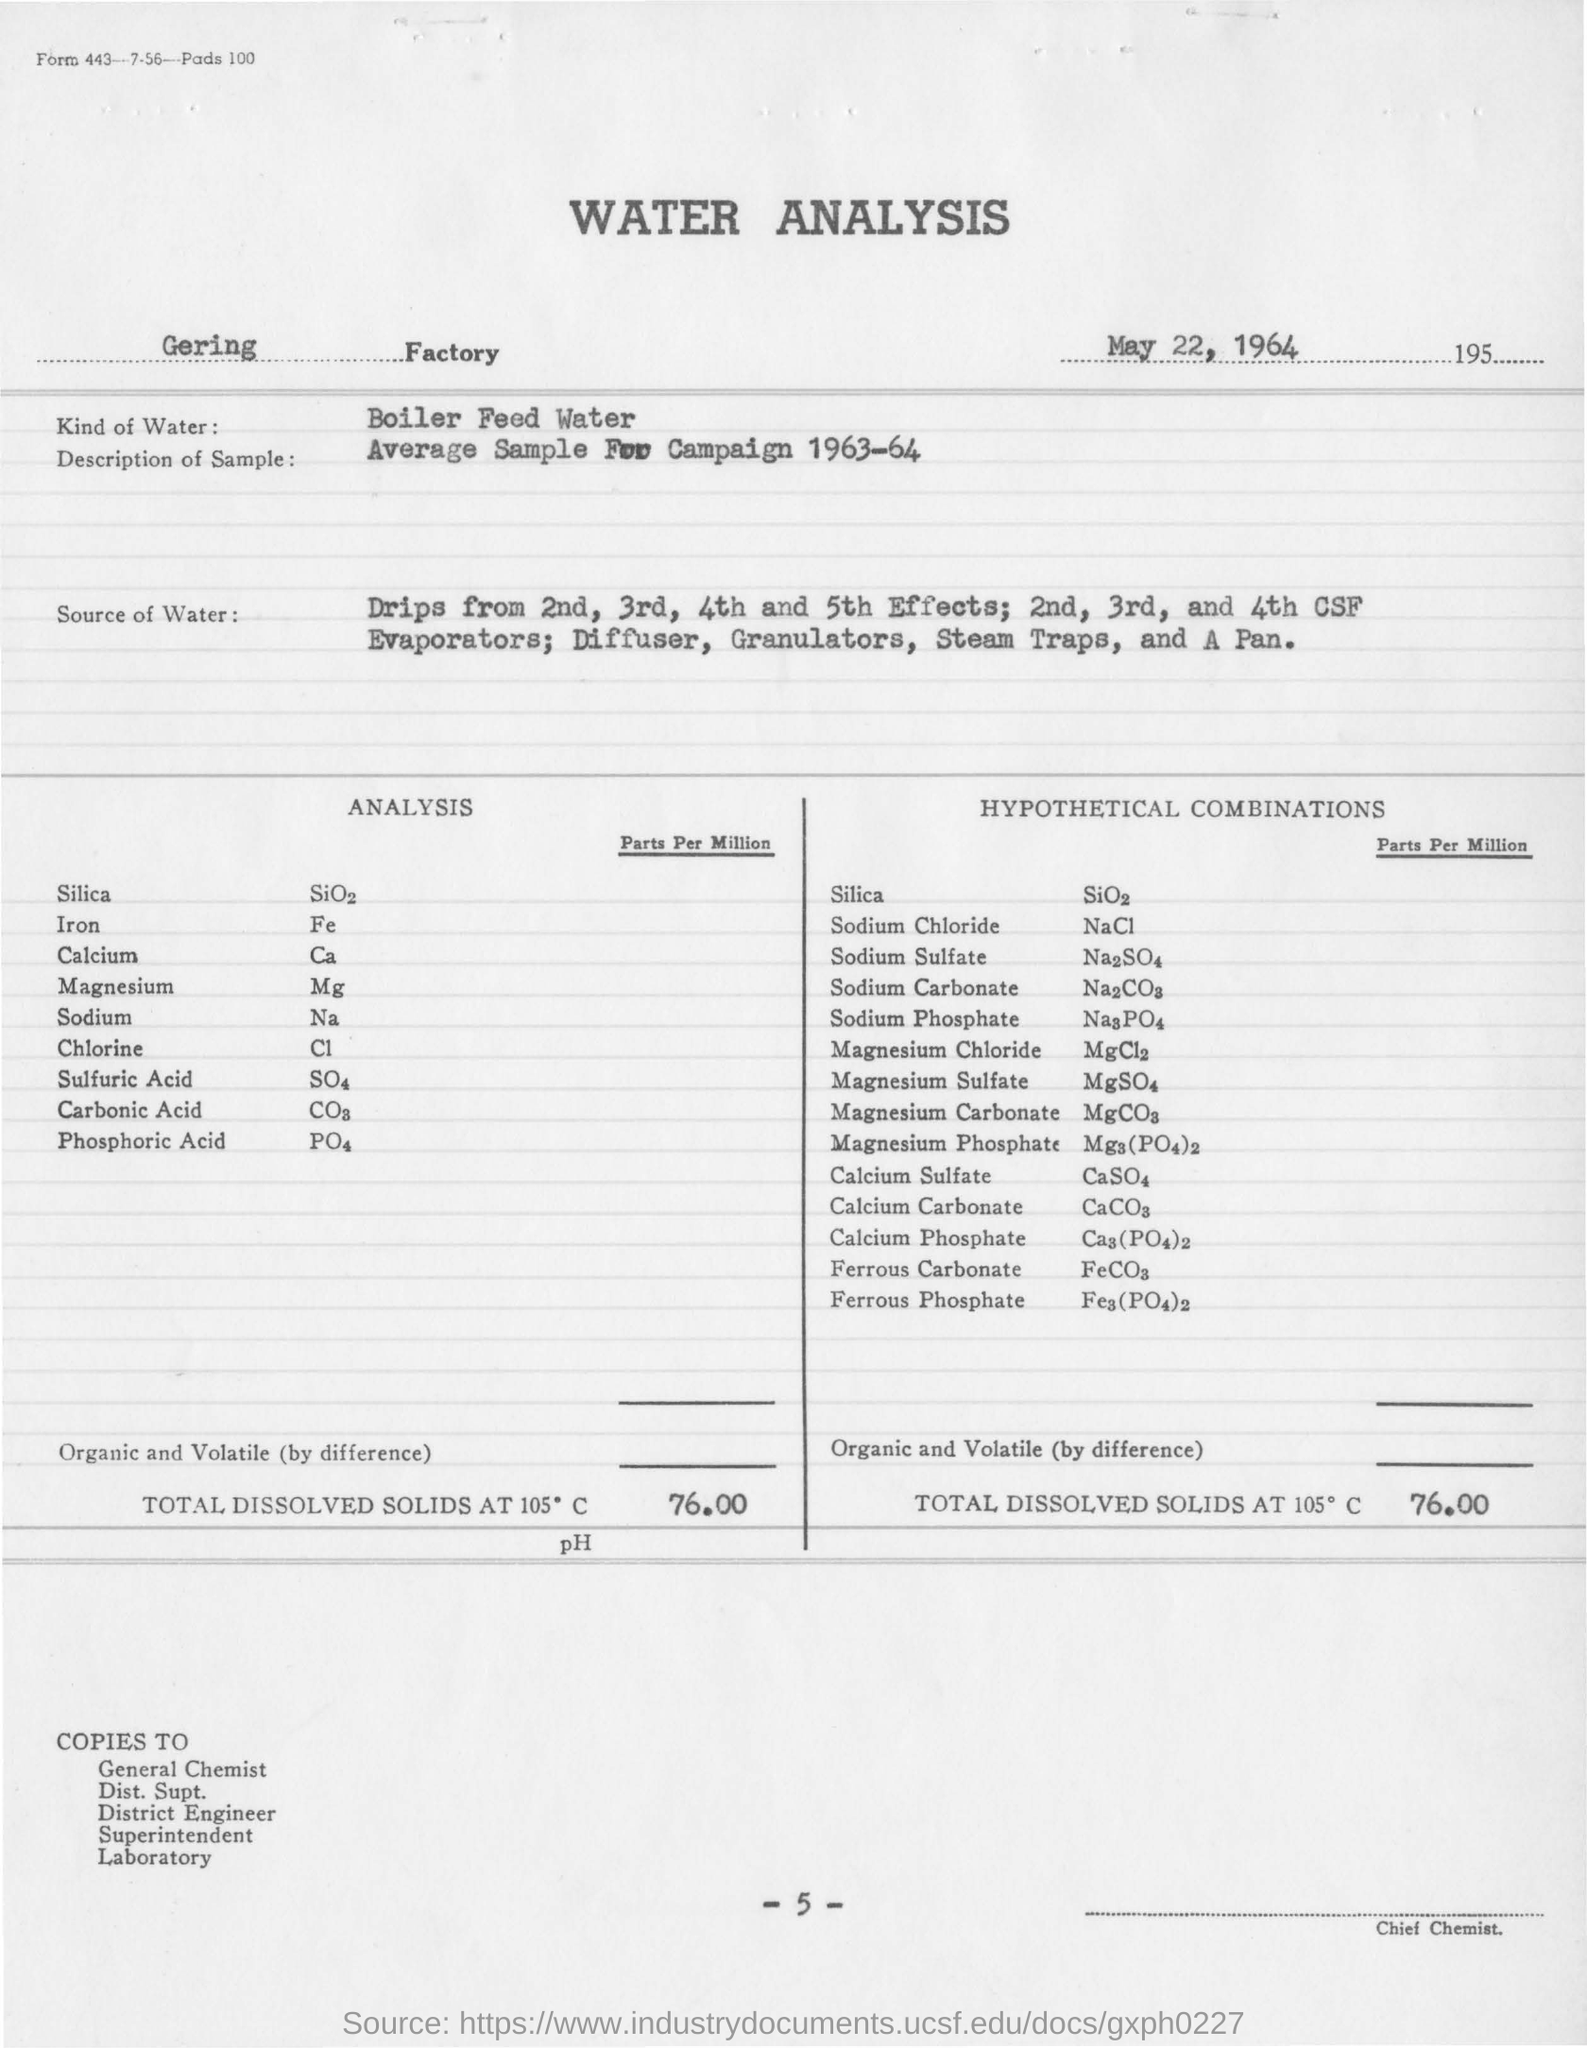what is the kind of water used in analysis ? The water analyzed in the provided image is Boiler Feed Water, which typically requires careful monitoring and treatment to ensure its suitability for use in boilers, where it will be converted into steam. The report details the analysis of a sample from the 1963-64 campaign that originated from drips from the second to the fifth effects, diffusers, granulators, steam traps, and a pan within the facility. It provides both the parts per million of various substances found in the water and hypothetical combinations of these substances. 